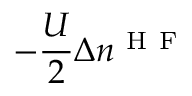<formula> <loc_0><loc_0><loc_500><loc_500>- \frac { U } { 2 } \Delta n ^ { H F }</formula> 